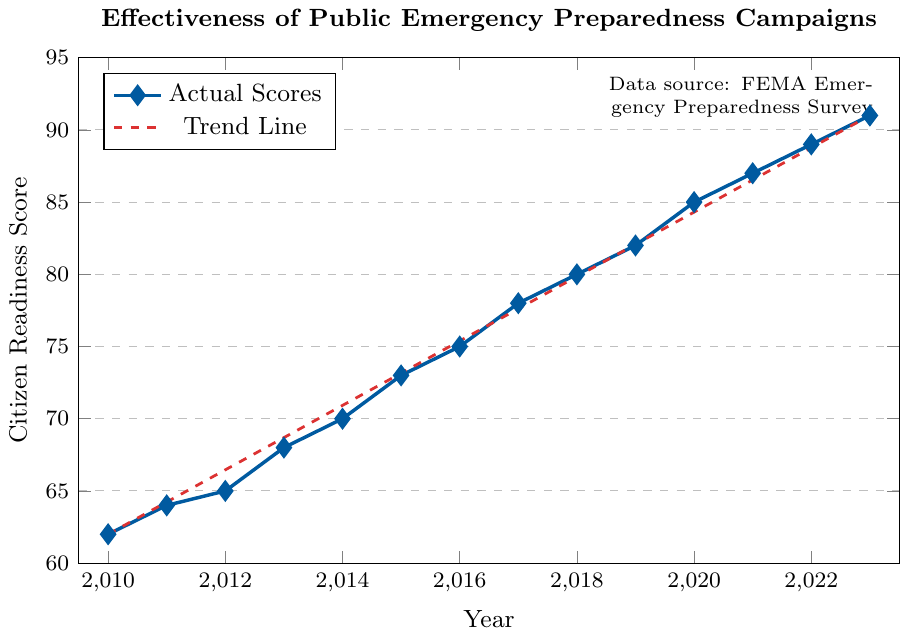What is the Citizen Readiness Score in 2015? Look for the point on the year 2015 and check its corresponding score. The score is labeled on the y-axis.
Answer: 73 What is the overall trend in Citizen Readiness Scores from 2010 to 2023? Look at the line and observe whether it is generally increasing, decreasing, or staying the same from left (2010) to right (2023). The line shows an upward trend.
Answer: Increasing How much did the Citizen Readiness Score increase from 2010 to 2023? Subtract the score in 2010 from the score in 2023. The score in 2010 is 62 and in 2023 is 91. 91 - 62 = 29
Answer: 29 During which year was the largest single-year increase in Citizen Readiness Score observed? Examine the data points to see where the largest jump occurs between consecutive years. The jump from 2020 (85) to 2021 (87) is the largest increase of 2 points each year, but this is ambiguous. Check the yearly points for exact clarity.
Answer: 2020-2021 Is the rate of increase in Citizen Readiness Scores steady throughout the years? Observe if the intervals between the data points are fairly consistent from 2010 to 2023. The rate of increase fluctuates slightly, with some years showing bigger jumps than others, such as between 2020 and 2021.
Answer: No What is the average Citizen Readiness Score from 2010 to 2023? Sum all the Citizen Readiness Scores from 2010 to 2023 and divide by the number of years (14). (62+64+65+68+70+73+75+78+80+82+85+87+89+91)/14 = 75.5
Answer: 75.5 By how much did the Citizen Readiness Score increase between 2013 and 2018? Subtract the score at 2013 from the score at 2018. The score in 2013 is 68 and in 2018 is 80. 80 - 68 = 12
Answer: 12 What is the difference between the Citizen Readiness Scores in 2010 and 2020? Subtract the score in 2010 from the score in 2020. The score in 2010 is 62 and the score in 2020 is 85. 85 - 62 = 23
Answer: 23 Does the trend line accurately reflect the rise in Citizen Readiness Scores between 2010 and 2023? Compare the trend line (dashed red) to the actual scores (blue line). The trend line closely follows the upward trajectory of the actual scores, indicating a good fit.
Answer: Yes 